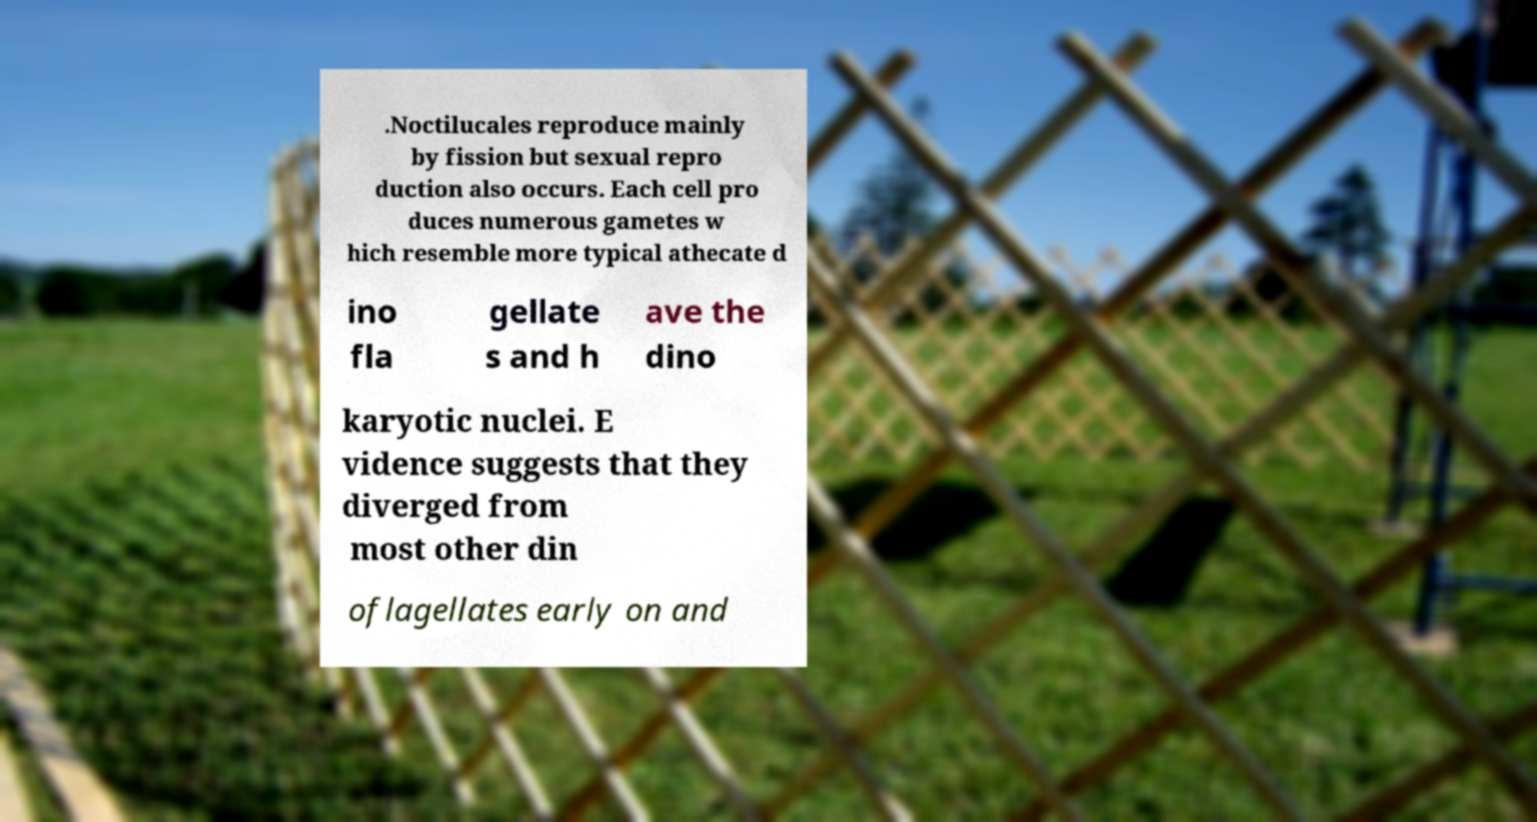Could you assist in decoding the text presented in this image and type it out clearly? .Noctilucales reproduce mainly by fission but sexual repro duction also occurs. Each cell pro duces numerous gametes w hich resemble more typical athecate d ino fla gellate s and h ave the dino karyotic nuclei. E vidence suggests that they diverged from most other din oflagellates early on and 